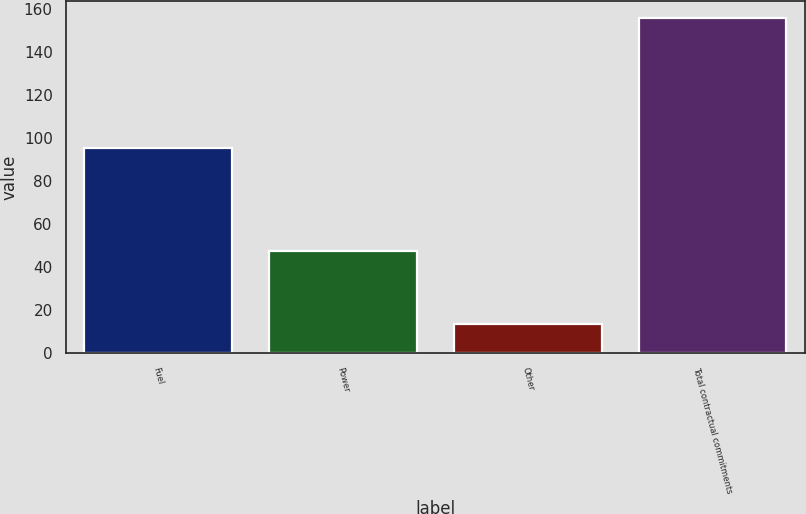<chart> <loc_0><loc_0><loc_500><loc_500><bar_chart><fcel>Fuel<fcel>Power<fcel>Other<fcel>Total contractual commitments<nl><fcel>95.3<fcel>47.4<fcel>13.4<fcel>156.1<nl></chart> 